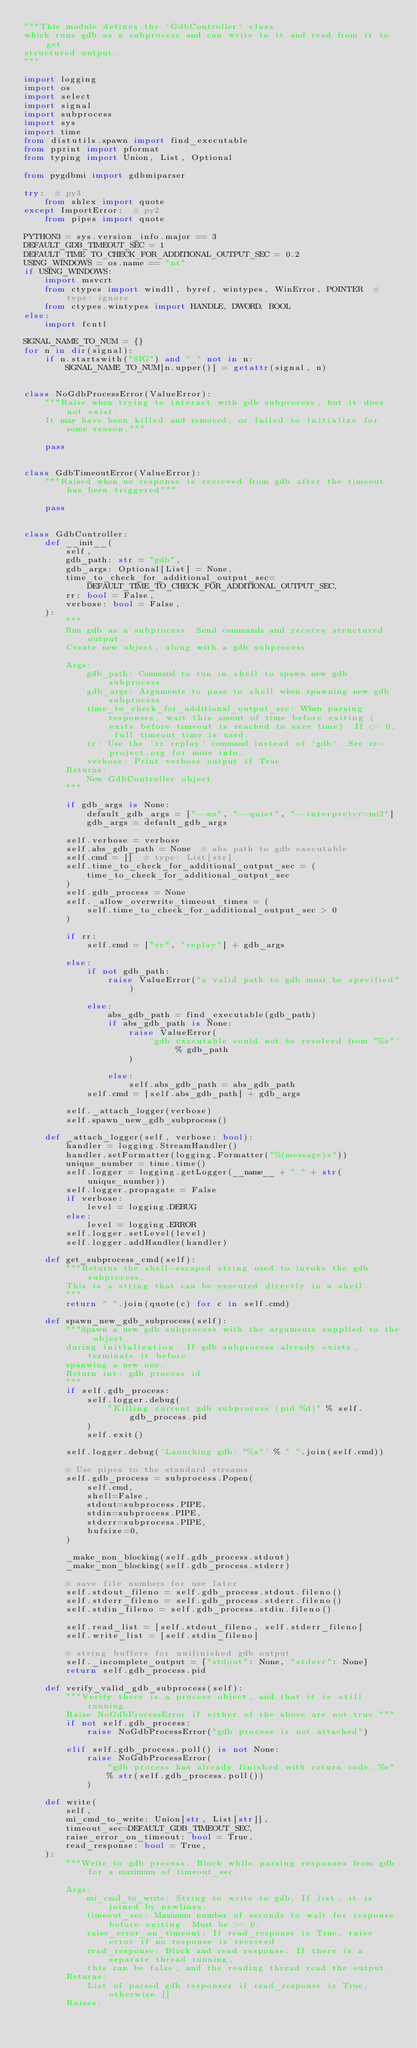Convert code to text. <code><loc_0><loc_0><loc_500><loc_500><_Python_>"""This module defines the `GdbController` class
which runs gdb as a subprocess and can write to it and read from it to get
structured output.
"""

import logging
import os
import select
import signal
import subprocess
import sys
import time
from distutils.spawn import find_executable
from pprint import pformat
from typing import Union, List, Optional

from pygdbmi import gdbmiparser

try:  # py3
    from shlex import quote
except ImportError:  # py2
    from pipes import quote

PYTHON3 = sys.version_info.major == 3
DEFAULT_GDB_TIMEOUT_SEC = 1
DEFAULT_TIME_TO_CHECK_FOR_ADDITIONAL_OUTPUT_SEC = 0.2
USING_WINDOWS = os.name == "nt"
if USING_WINDOWS:
    import msvcrt
    from ctypes import windll, byref, wintypes, WinError, POINTER  # type: ignore
    from ctypes.wintypes import HANDLE, DWORD, BOOL
else:
    import fcntl

SIGNAL_NAME_TO_NUM = {}
for n in dir(signal):
    if n.startswith("SIG") and "_" not in n:
        SIGNAL_NAME_TO_NUM[n.upper()] = getattr(signal, n)


class NoGdbProcessError(ValueError):
    """Raise when trying to interact with gdb subprocess, but it does not exist.
    It may have been killed and removed, or failed to initialize for some reason."""

    pass


class GdbTimeoutError(ValueError):
    """Raised when no response is recieved from gdb after the timeout has been triggered"""

    pass


class GdbController:
    def __init__(
        self,
        gdb_path: str = "gdb",
        gdb_args: Optional[List] = None,
        time_to_check_for_additional_output_sec=DEFAULT_TIME_TO_CHECK_FOR_ADDITIONAL_OUTPUT_SEC,
        rr: bool = False,
        verbose: bool = False,
    ):
        """
        Run gdb as a subprocess. Send commands and receive structured output.
        Create new object, along with a gdb subprocess

        Args:
            gdb_path: Command to run in shell to spawn new gdb subprocess
            gdb_args: Arguments to pass to shell when spawning new gdb subprocess
            time_to_check_for_additional_output_sec: When parsing responses, wait this amout of time before exiting (exits before timeout is reached to save time). If <= 0, full timeout time is used.
            rr: Use the `rr replay` command instead of `gdb`. See rr-project.org for more info.
            verbose: Print verbose output if True
        Returns:
            New GdbController object
        """

        if gdb_args is None:
            default_gdb_args = ["--nx", "--quiet", "--interpreter=mi2"]
            gdb_args = default_gdb_args

        self.verbose = verbose
        self.abs_gdb_path = None  # abs path to gdb executable
        self.cmd = []  # type: List[str]
        self.time_to_check_for_additional_output_sec = (
            time_to_check_for_additional_output_sec
        )
        self.gdb_process = None
        self._allow_overwrite_timeout_times = (
            self.time_to_check_for_additional_output_sec > 0
        )

        if rr:
            self.cmd = ["rr", "replay"] + gdb_args

        else:
            if not gdb_path:
                raise ValueError("a valid path to gdb must be specified")

            else:
                abs_gdb_path = find_executable(gdb_path)
                if abs_gdb_path is None:
                    raise ValueError(
                        'gdb executable could not be resolved from "%s"' % gdb_path
                    )

                else:
                    self.abs_gdb_path = abs_gdb_path
            self.cmd = [self.abs_gdb_path] + gdb_args

        self._attach_logger(verbose)
        self.spawn_new_gdb_subprocess()

    def _attach_logger(self, verbose: bool):
        handler = logging.StreamHandler()
        handler.setFormatter(logging.Formatter("%(message)s"))
        unique_number = time.time()
        self.logger = logging.getLogger(__name__ + "." + str(unique_number))
        self.logger.propagate = False
        if verbose:
            level = logging.DEBUG
        else:
            level = logging.ERROR
        self.logger.setLevel(level)
        self.logger.addHandler(handler)

    def get_subprocess_cmd(self):
        """Returns the shell-escaped string used to invoke the gdb subprocess.
        This is a string that can be executed directly in a shell.
        """
        return " ".join(quote(c) for c in self.cmd)

    def spawn_new_gdb_subprocess(self):
        """Spawn a new gdb subprocess with the arguments supplied to the object
        during initialization. If gdb subprocess already exists, terminate it before
        spanwing a new one.
        Return int: gdb process id
        """
        if self.gdb_process:
            self.logger.debug(
                "Killing current gdb subprocess (pid %d)" % self.gdb_process.pid
            )
            self.exit()

        self.logger.debug('Launching gdb: "%s"' % " ".join(self.cmd))

        # Use pipes to the standard streams
        self.gdb_process = subprocess.Popen(
            self.cmd,
            shell=False,
            stdout=subprocess.PIPE,
            stdin=subprocess.PIPE,
            stderr=subprocess.PIPE,
            bufsize=0,
        )

        _make_non_blocking(self.gdb_process.stdout)
        _make_non_blocking(self.gdb_process.stderr)

        # save file numbers for use later
        self.stdout_fileno = self.gdb_process.stdout.fileno()
        self.stderr_fileno = self.gdb_process.stderr.fileno()
        self.stdin_fileno = self.gdb_process.stdin.fileno()

        self.read_list = [self.stdout_fileno, self.stderr_fileno]
        self.write_list = [self.stdin_fileno]

        # string buffers for unifinished gdb output
        self._incomplete_output = {"stdout": None, "stderr": None}
        return self.gdb_process.pid

    def verify_valid_gdb_subprocess(self):
        """Verify there is a process object, and that it is still running.
        Raise NoGdbProcessError if either of the above are not true."""
        if not self.gdb_process:
            raise NoGdbProcessError("gdb process is not attached")

        elif self.gdb_process.poll() is not None:
            raise NoGdbProcessError(
                "gdb process has already finished with return code: %s"
                % str(self.gdb_process.poll())
            )

    def write(
        self,
        mi_cmd_to_write: Union[str, List[str]],
        timeout_sec=DEFAULT_GDB_TIMEOUT_SEC,
        raise_error_on_timeout: bool = True,
        read_response: bool = True,
    ):
        """Write to gdb process. Block while parsing responses from gdb for a maximum of timeout_sec.

        Args:
            mi_cmd_to_write: String to write to gdb. If list, it is joined by newlines.
            timeout_sec: Maximum number of seconds to wait for response before exiting. Must be >= 0.
            raise_error_on_timeout: If read_response is True, raise error if no response is received
            read_response: Block and read response. If there is a separate thread running,
            this can be false, and the reading thread read the output.
        Returns:
            List of parsed gdb responses if read_response is True, otherwise []
        Raises:</code> 